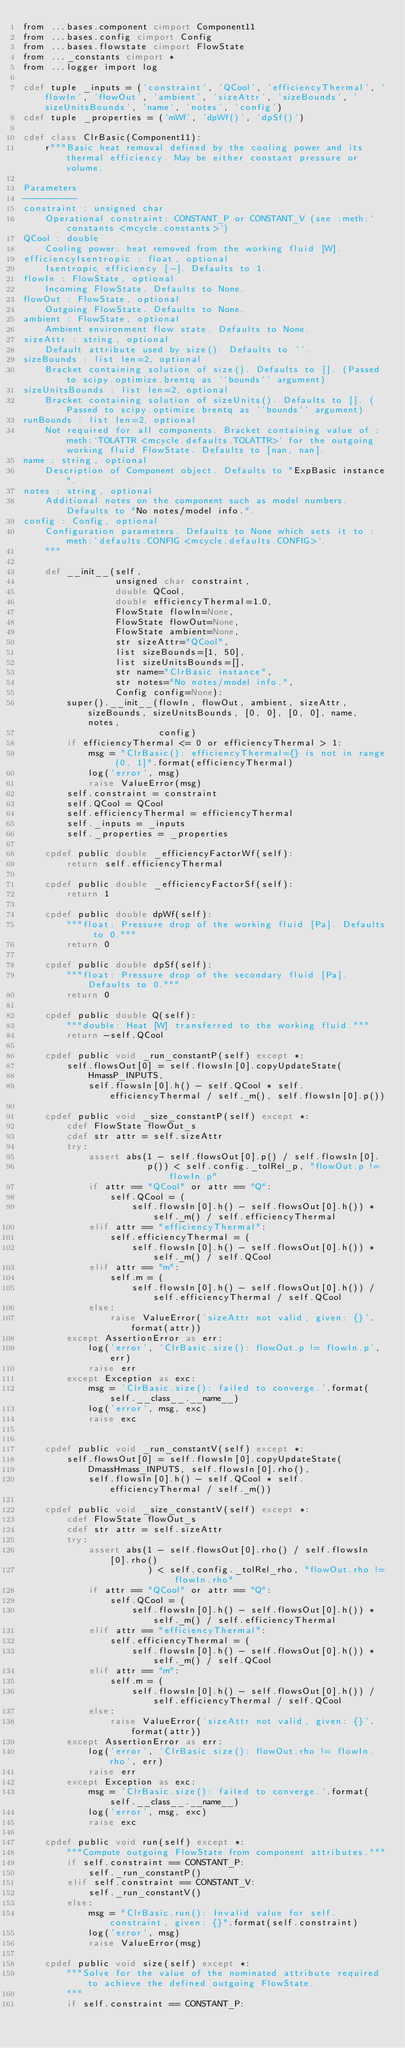Convert code to text. <code><loc_0><loc_0><loc_500><loc_500><_Cython_>from ...bases.component cimport Component11
from ...bases.config cimport Config
from ...bases.flowstate cimport FlowState
from ..._constants cimport *
from ...logger import log

cdef tuple _inputs = ('constraint', 'QCool', 'efficiencyThermal', 'flowIn', 'flowOut', 'ambient', 'sizeAttr', 'sizeBounds', 'sizeUnitsBounds', 'name', 'notes', 'config')
cdef tuple _properties = ('mWf', 'dpWf()', 'dpSf()')
        
cdef class ClrBasic(Component11):
    r"""Basic heat removal defined by the cooling power and its thermal efficiency. May be either constant pressure or volume.

Parameters
----------
constraint : unsigned char
    Operational constraint: CONSTANT_P or CONSTANT_V (see :meth:`constants <mcycle.constants>`)
QCool : double
    Cooling power: heat removed from the working fluid [W].
efficiencyIsentropic : float, optional
    Isentropic efficiency [-]. Defaults to 1.
flowIn : FlowState, optional
    Incoming FlowState. Defaults to None.
flowOut : FlowState, optional
    Outgoing FlowState. Defaults to None.
ambient : FlowState, optional
    Ambient environment flow state. Defaults to None.
sizeAttr : string, optional
    Default attribute used by size(). Defaults to ''.
sizeBounds : list len=2, optional
    Bracket containing solution of size(). Defaults to []. (Passed to scipy.optimize.brentq as ``bounds`` argument)
sizeUnitsBounds : list len=2, optional
    Bracket containing solution of sizeUnits(). Defaults to []. (Passed to scipy.optimize.brentq as ``bounds`` argument)
runBounds : list len=2, optional
    Not required for all components. Bracket containing value of :meth:`TOLATTR <mcycle.defaults.TOLATTR>` for the outgoing working fluid FlowState. Defaults to [nan, nan]. 
name : string, optional
    Description of Component object. Defaults to "ExpBasic instance".
notes : string, optional
    Additional notes on the component such as model numbers. Defaults to "No notes/model info.".
config : Config, optional
    Configuration parameters. Defaults to None which sets it to :meth:`defaults.CONFIG <mcycle.defaults.CONFIG>`.
    """

    def __init__(self,
                 unsigned char constraint,
                 double QCool,
                 double efficiencyThermal=1.0,
                 FlowState flowIn=None,
                 FlowState flowOut=None,
                 FlowState ambient=None,
                 str sizeAttr="QCool",
                 list sizeBounds=[1, 50],
                 list sizeUnitsBounds=[],
                 str name="ClrBasic instance",
                 str notes="No notes/model info.",
                 Config config=None):
        super().__init__(flowIn, flowOut, ambient, sizeAttr, sizeBounds, sizeUnitsBounds, [0, 0], [0, 0], name, notes,
                         config)
        if efficiencyThermal <= 0 or efficiencyThermal > 1:
            msg = "ClrBasic(): efficiencyThermal={} is not in range (0, 1]".format(efficiencyThermal)
            log('error', msg)
            raise ValueError(msg)
        self.constraint = constraint
        self.QCool = QCool
        self.efficiencyThermal = efficiencyThermal
        self._inputs = _inputs
        self._properties = _properties

    cpdef public double _efficiencyFactorWf(self):
        return self.efficiencyThermal
    
    cpdef public double _efficiencyFactorSf(self):
        return 1

    cpdef public double dpWf(self):
        """float: Pressure drop of the working fluid [Pa]. Defaults to 0."""
        return 0

    cpdef public double dpSf(self):
        """float: Pressure drop of the secondary fluid [Pa]. Defaults to 0."""
        return 0
            
    cpdef public double Q(self):
        """double: Heat [W] transferred to the working fluid."""
        return -self.QCool

    cpdef public void _run_constantP(self) except *:
        self.flowsOut[0] = self.flowsIn[0].copyUpdateState(
            HmassP_INPUTS,
            self.flowsIn[0].h() - self.QCool * self.efficiencyThermal / self._m(), self.flowsIn[0].p())

    cpdef public void _size_constantP(self) except *:
        cdef FlowState flowOut_s
        cdef str attr = self.sizeAttr
        try:
            assert abs(1 - self.flowsOut[0].p() / self.flowsIn[0].
                       p()) < self.config._tolRel_p, "flowOut.p != flowIn.p"
            if attr == "QCool" or attr == "Q":
                self.QCool = (
                    self.flowsIn[0].h() - self.flowsOut[0].h()) * self._m() / self.efficiencyThermal
            elif attr == "efficiencyThermal":
                self.efficiencyThermal = (
                    self.flowsIn[0].h() - self.flowsOut[0].h()) * self._m() / self.QCool
            elif attr == "m":
                self.m = (
                    self.flowsIn[0].h() - self.flowsOut[0].h()) / self.efficiencyThermal / self.QCool
            else:
                raise ValueError('sizeAttr not valid, given: {}'.format(attr))
        except AssertionError as err:
            log('error', 'ClrBasic.size(): flowOut.p != flowIn.p', err)
            raise err
        except Exception as exc:
            msg = 'ClrBasic.size(): failed to converge.'.format(self.__class__.__name__)
            log('error', msg, exc)
            raise exc

        
    cpdef public void _run_constantV(self) except *:
        self.flowsOut[0] = self.flowsIn[0].copyUpdateState(
            DmassHmass_INPUTS, self.flowsIn[0].rho(),
            self.flowsIn[0].h() - self.QCool * self.efficiencyThermal / self._m())

    cpdef public void _size_constantV(self) except *:
        cdef FlowState flowOut_s
        cdef str attr = self.sizeAttr
        try:
            assert abs(1 - self.flowsOut[0].rho() / self.flowsIn[0].rho()
                       ) < self.config._tolRel_rho, "flowOut.rho != flowIn.rho"
            if attr == "QCool" or attr == "Q":
                self.QCool = (
                    self.flowsIn[0].h() - self.flowsOut[0].h()) * self._m() / self.efficiencyThermal
            elif attr == "efficiencyThermal":
                self.efficiencyThermal = (
                    self.flowsIn[0].h() - self.flowsOut[0].h()) * self._m() / self.QCool
            elif attr == "m":
                self.m = (
                    self.flowsIn[0].h() - self.flowsOut[0].h()) / self.efficiencyThermal / self.QCool
            else:
                raise ValueError('sizeAttr not valid, given: {}'.format(attr))
        except AssertionError as err:
            log('error', 'ClrBasic.size(): flowOut.rho != flowIn.rho', err)
            raise err
        except Exception as exc:
            msg = 'ClrBasic.size(): failed to converge.'.format(self.__class__.__name__)
            log('error', msg, exc)
            raise exc

    cpdef public void run(self) except *:
        """Compute outgoing FlowState from component attributes."""
        if self.constraint == CONSTANT_P:
            self._run_constantP()
        elif self.constraint == CONSTANT_V:
            self._run_constantV()
        else:
            msg = "ClrBasic.run(): Invalid value for self.constraint, given: {}".format(self.constraint)
            log('error', msg)
            raise ValueError(msg)

    cpdef public void size(self) except *:
        """Solve for the value of the nominated attribute required to achieve the defined outgoing FlowState.
        """
        if self.constraint == CONSTANT_P:</code> 